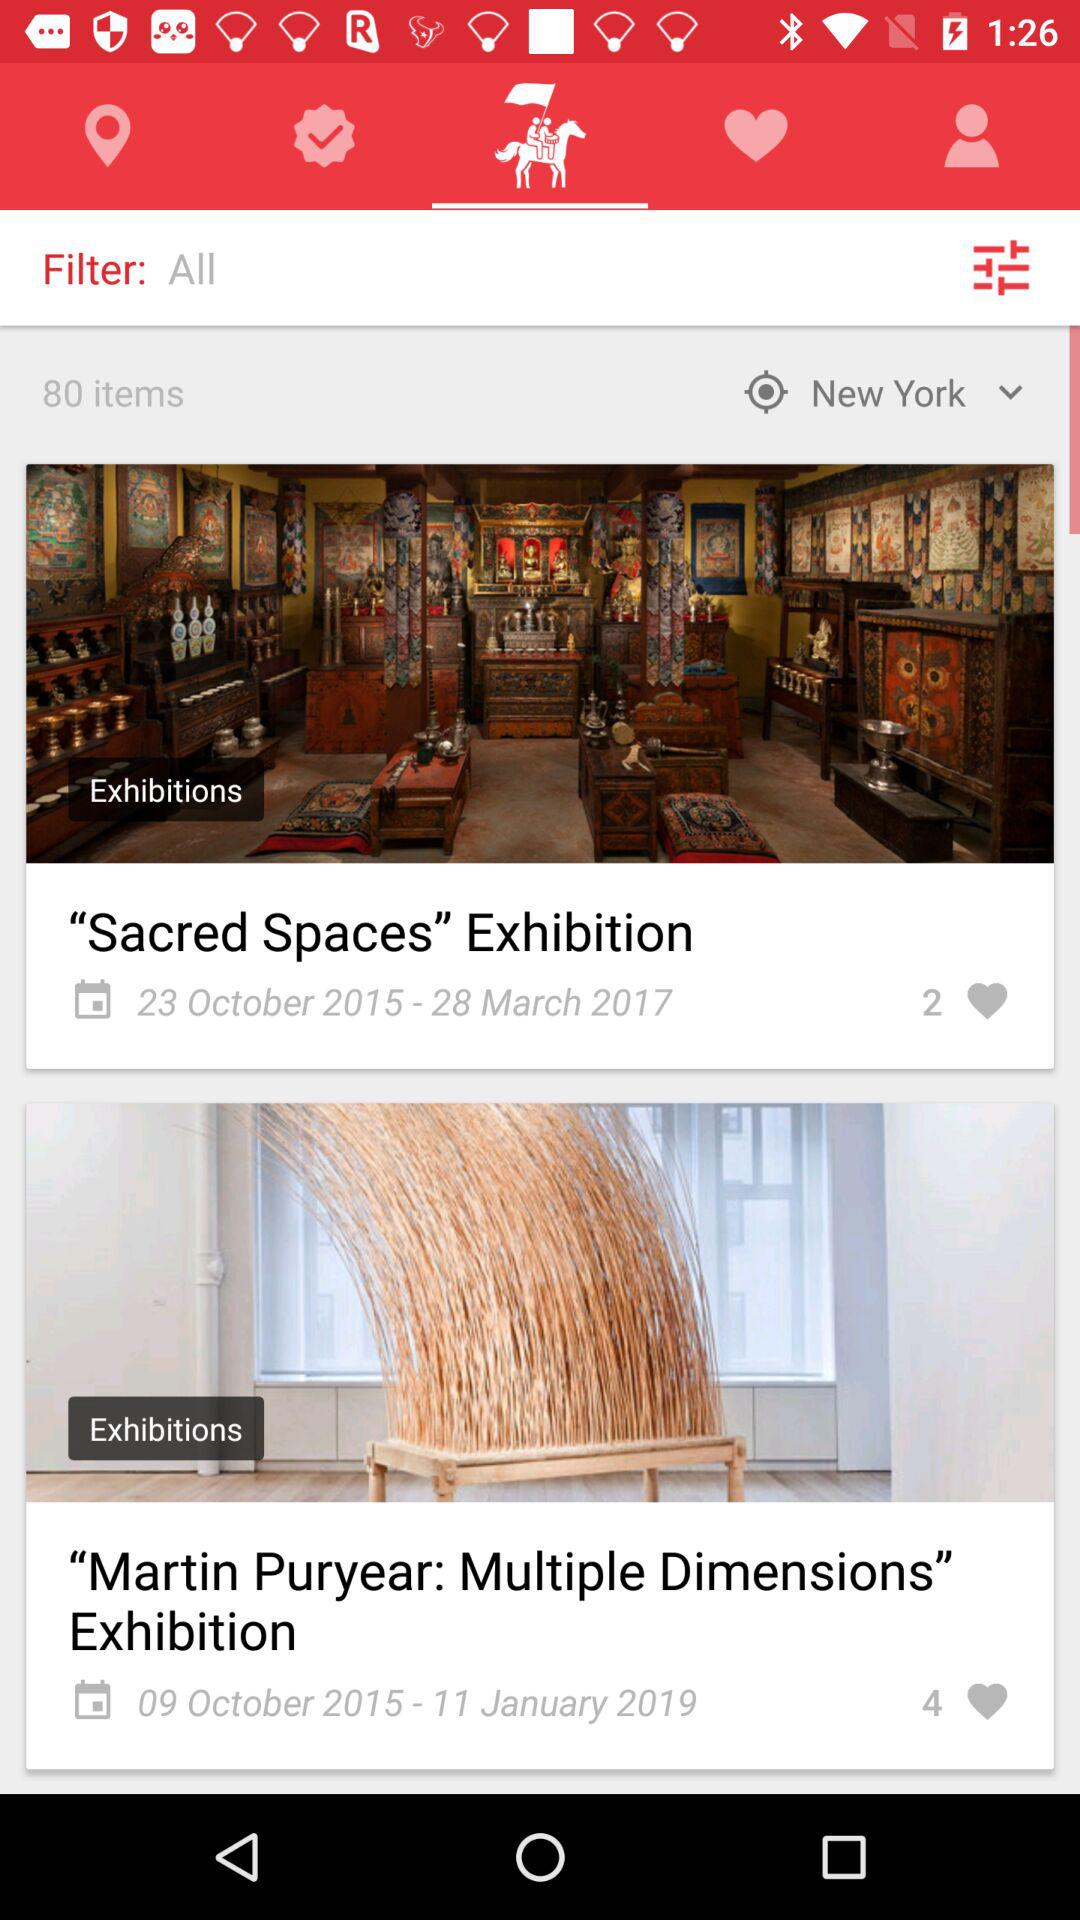How many more hearts does the second item have than the first?
Answer the question using a single word or phrase. 2 